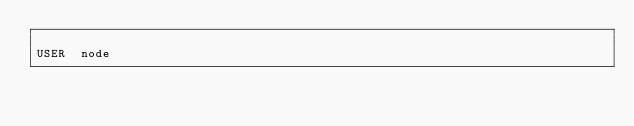Convert code to text. <code><loc_0><loc_0><loc_500><loc_500><_Dockerfile_>
USER  node



</code> 